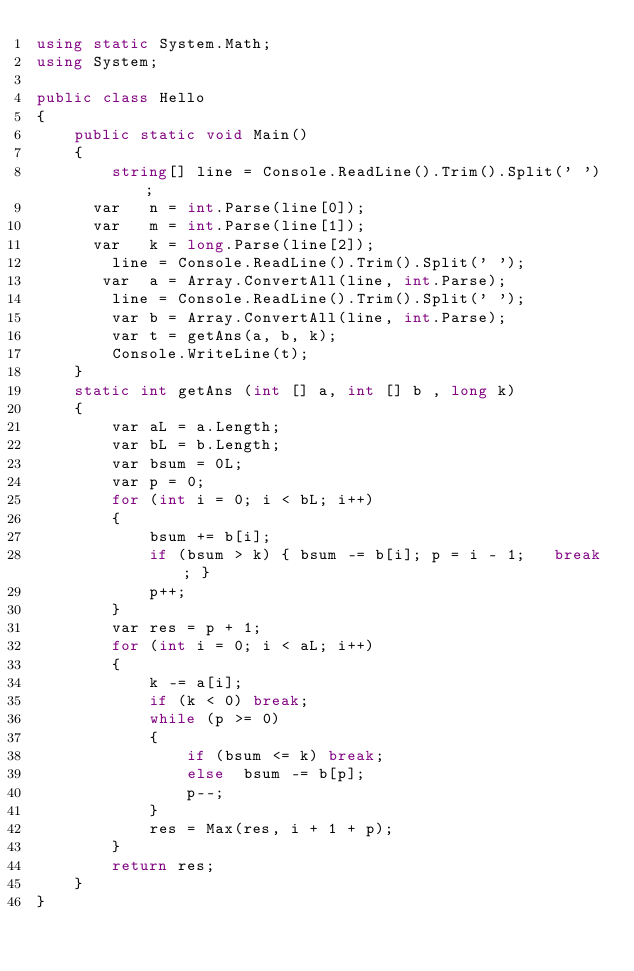Convert code to text. <code><loc_0><loc_0><loc_500><loc_500><_C#_>using static System.Math;
using System;

public class Hello
{
    public static void Main()
    {
        string[] line = Console.ReadLine().Trim().Split(' ');
      var   n = int.Parse(line[0]);
      var   m = int.Parse(line[1]);
      var   k = long.Parse(line[2]);
        line = Console.ReadLine().Trim().Split(' ');
       var  a = Array.ConvertAll(line, int.Parse);
        line = Console.ReadLine().Trim().Split(' ');
        var b = Array.ConvertAll(line, int.Parse);
        var t = getAns(a, b, k);
        Console.WriteLine(t);
    }
    static int getAns (int [] a, int [] b , long k)
    {
        var aL = a.Length;
        var bL = b.Length;
        var bsum = 0L;
        var p = 0;
        for (int i = 0; i < bL; i++)
        {
            bsum += b[i];
            if (bsum > k) { bsum -= b[i]; p = i - 1;   break; }
            p++;
        }
        var res = p + 1;
        for (int i = 0; i < aL; i++)
        {
            k -= a[i];
            if (k < 0) break;
            while (p >= 0)
            {
                if (bsum <= k) break;
                else  bsum -= b[p];
                p--;
            }
            res = Max(res, i + 1 + p);
        }
        return res;
    }
}
</code> 